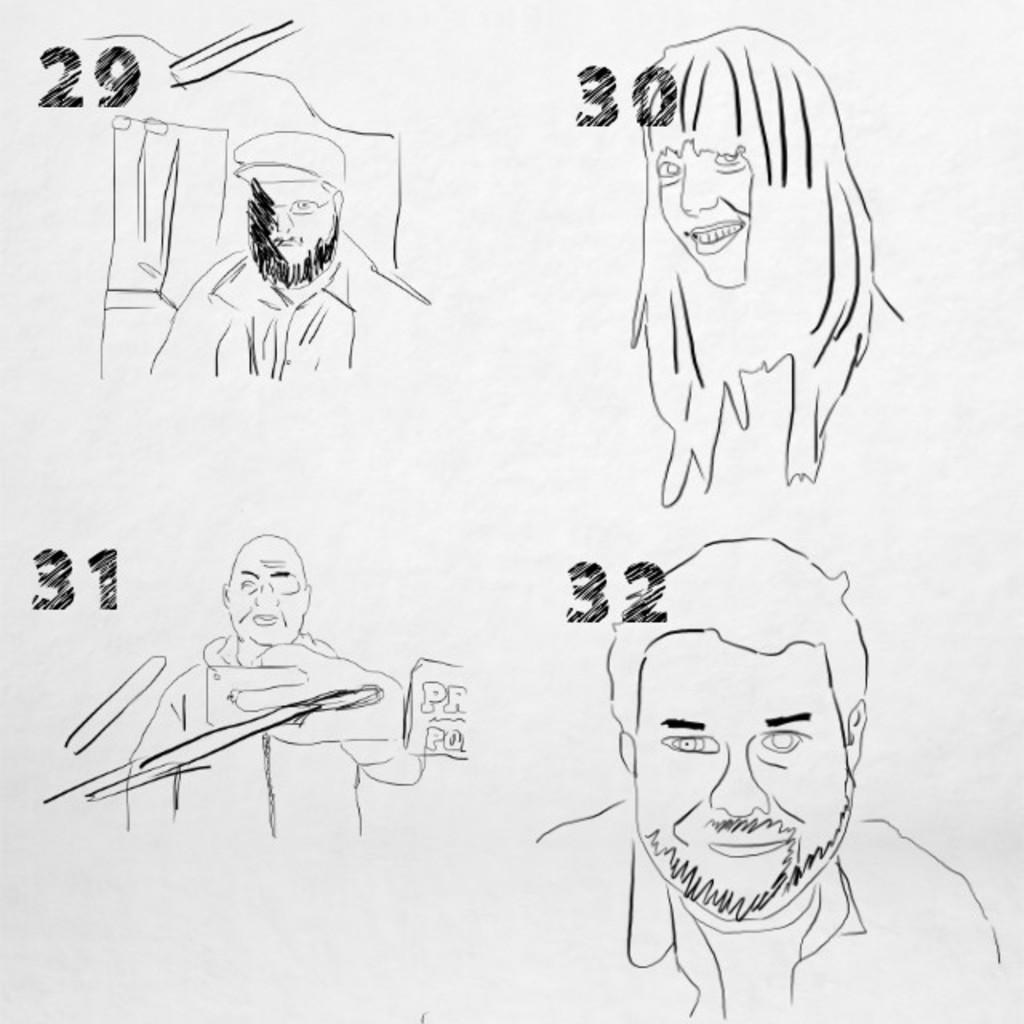How would you summarize this image in a sentence or two? In this picture there is a poster on which there are faces of different people. 